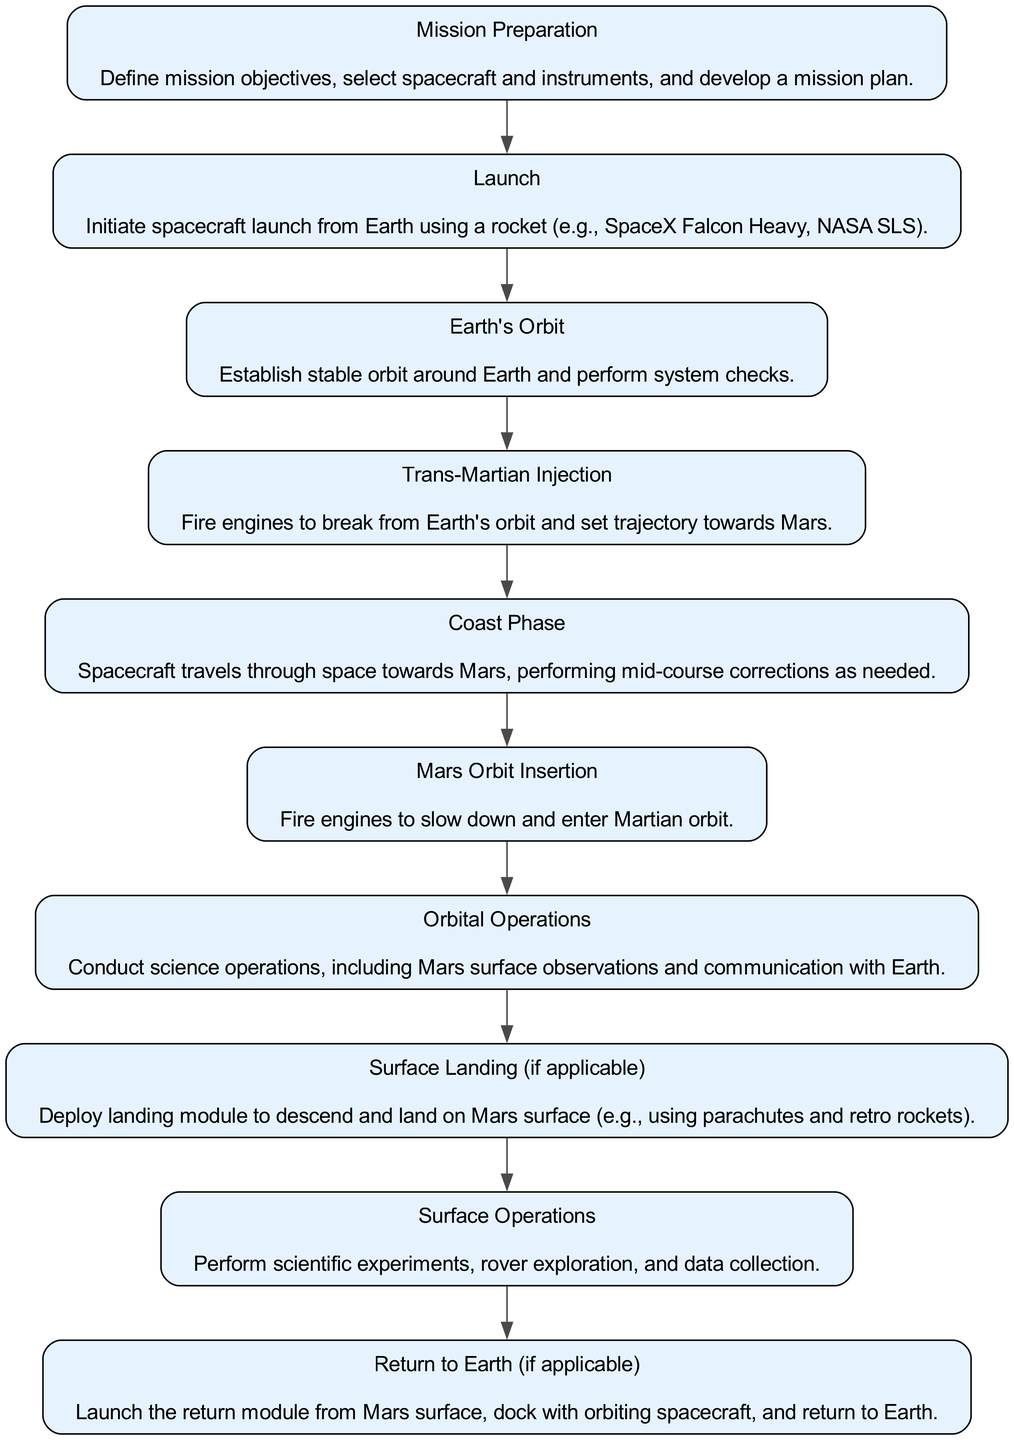What is the first step in the spacecraft journey? The first step mentioned in the diagram is "Mission Preparation," which outlines defining mission objectives and planning.
Answer: Mission Preparation How many main stages are there in the journey to Mars? By counting the distinct elements in the diagram, there are 10 main stages leading to Mars.
Answer: 10 What happens after the 'Launch' stage? After the 'Launch,' the next stage is 'Earth's Orbit,' where the spacecraft establishes a stable orbit and performs system checks.
Answer: Earth's Orbit Which stage involves entering Martian orbit? The stage that involves entering Martian orbit is 'Mars Orbit Insertion,' where engines are fired to slow down the spacecraft.
Answer: Mars Orbit Insertion What is required for 'Surface Landing'? The 'Surface Landing' stage requires deploying a landing module to descend and land on Mars’ surface.
Answer: Deploy landing module What is the last stage if the mission includes a return to Earth? If the mission includes a return to Earth, the last stage is 'Return to Earth,' which involves launching a return module from the Martian surface.
Answer: Return to Earth What phase involves adjusting the spacecraft’s trajectory? The phase that involves adjusting the spacecraft's trajectory is called 'Coast Phase,' where mid-course corrections are performed.
Answer: Coast Phase How is the 'Orbital Operations' phase described in the diagram? 'Orbital Operations' is described as conducting science operations, including Mars surface observations and communication with Earth.
Answer: Conduct science operations Which stage directly follows 'Trans-Martian Injection'? After 'Trans-Martian Injection,' the spacecraft enters the 'Coast Phase,' where it travels towards Mars.
Answer: Coast Phase What critical action occurs during the 'Mars Orbit Insertion'? During the 'Mars Orbit Insertion,' the critical action taken is firing engines to slow down and enter Martian orbit.
Answer: Firing engines 